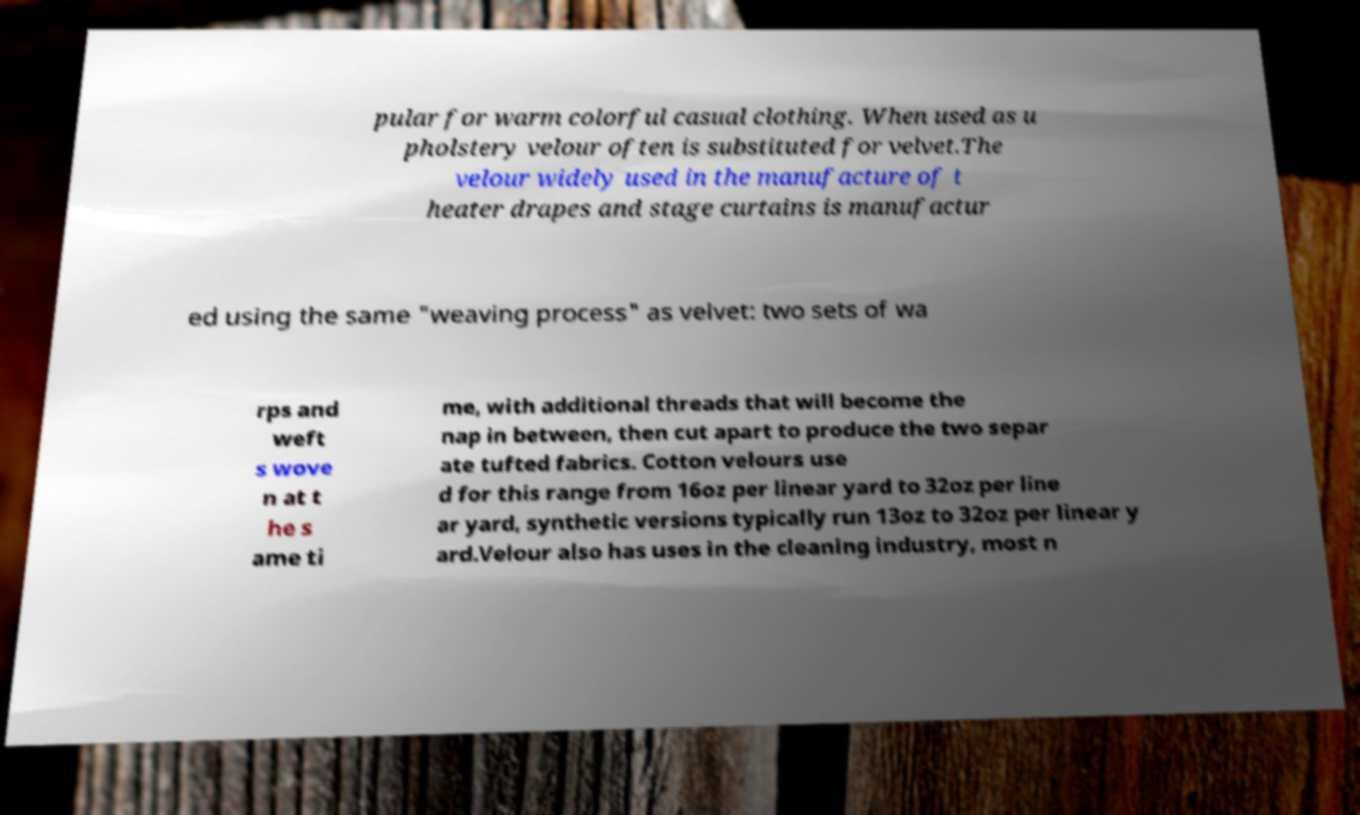There's text embedded in this image that I need extracted. Can you transcribe it verbatim? pular for warm colorful casual clothing. When used as u pholstery velour often is substituted for velvet.The velour widely used in the manufacture of t heater drapes and stage curtains is manufactur ed using the same "weaving process" as velvet: two sets of wa rps and weft s wove n at t he s ame ti me, with additional threads that will become the nap in between, then cut apart to produce the two separ ate tufted fabrics. Cotton velours use d for this range from 16oz per linear yard to 32oz per line ar yard, synthetic versions typically run 13oz to 32oz per linear y ard.Velour also has uses in the cleaning industry, most n 